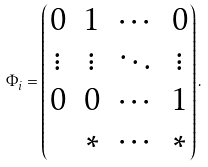<formula> <loc_0><loc_0><loc_500><loc_500>\Phi _ { i } = \begin{pmatrix} 0 & 1 & \cdots & 0 \\ \vdots & \vdots & \ddots & \vdots \\ 0 & 0 & \cdots & 1 \\ & * & \cdots & * \end{pmatrix} .</formula> 